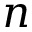<formula> <loc_0><loc_0><loc_500><loc_500>n</formula> 